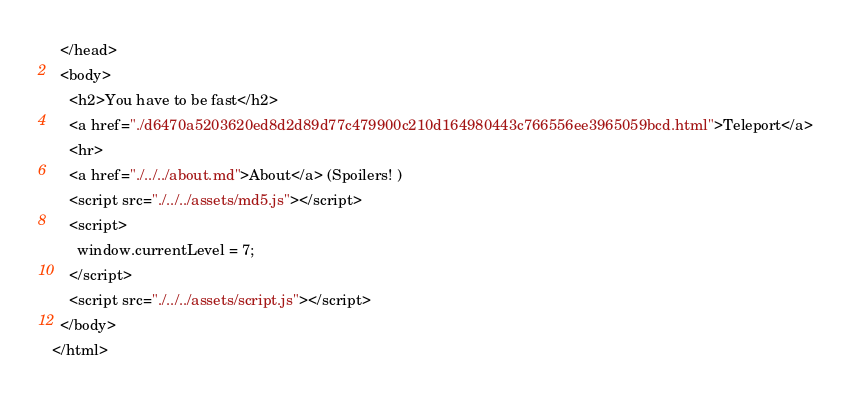<code> <loc_0><loc_0><loc_500><loc_500><_HTML_>  </head>
  <body>
    <h2>You have to be fast</h2>
    <a href="./d6470a5203620ed8d2d89d77c479900c210d164980443c766556ee3965059bcd.html">Teleport</a>
    <hr>
    <a href="./../../about.md">About</a> (Spoilers! )
    <script src="./../../assets/md5.js"></script>
    <script>
      window.currentLevel = 7;
    </script>
    <script src="./../../assets/script.js"></script>
  </body>
</html></code> 